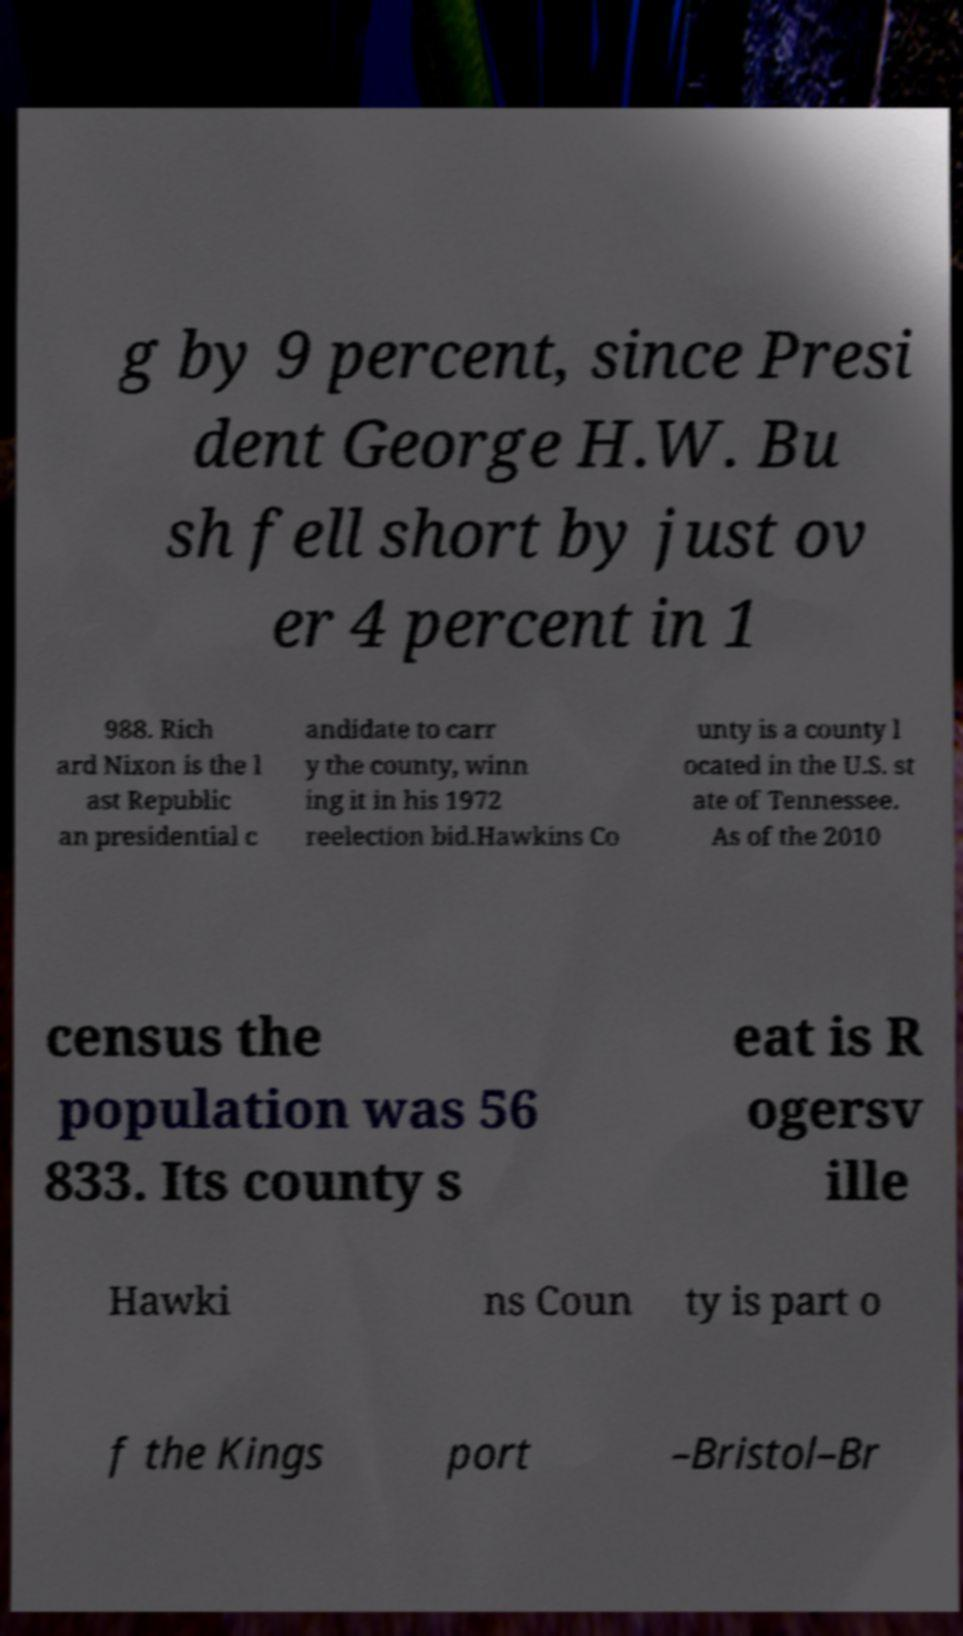Can you read and provide the text displayed in the image?This photo seems to have some interesting text. Can you extract and type it out for me? g by 9 percent, since Presi dent George H.W. Bu sh fell short by just ov er 4 percent in 1 988. Rich ard Nixon is the l ast Republic an presidential c andidate to carr y the county, winn ing it in his 1972 reelection bid.Hawkins Co unty is a county l ocated in the U.S. st ate of Tennessee. As of the 2010 census the population was 56 833. Its county s eat is R ogersv ille Hawki ns Coun ty is part o f the Kings port –Bristol–Br 